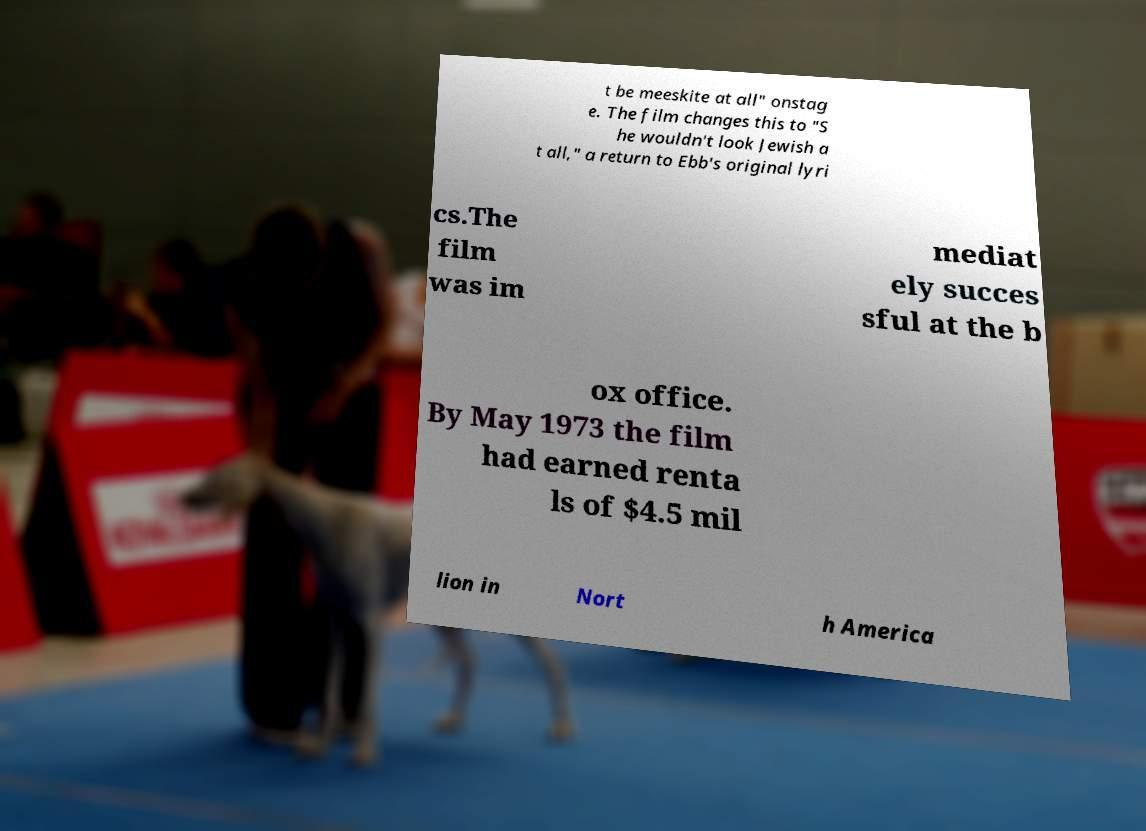Can you accurately transcribe the text from the provided image for me? t be meeskite at all" onstag e. The film changes this to "S he wouldn't look Jewish a t all," a return to Ebb's original lyri cs.The film was im mediat ely succes sful at the b ox office. By May 1973 the film had earned renta ls of $4.5 mil lion in Nort h America 